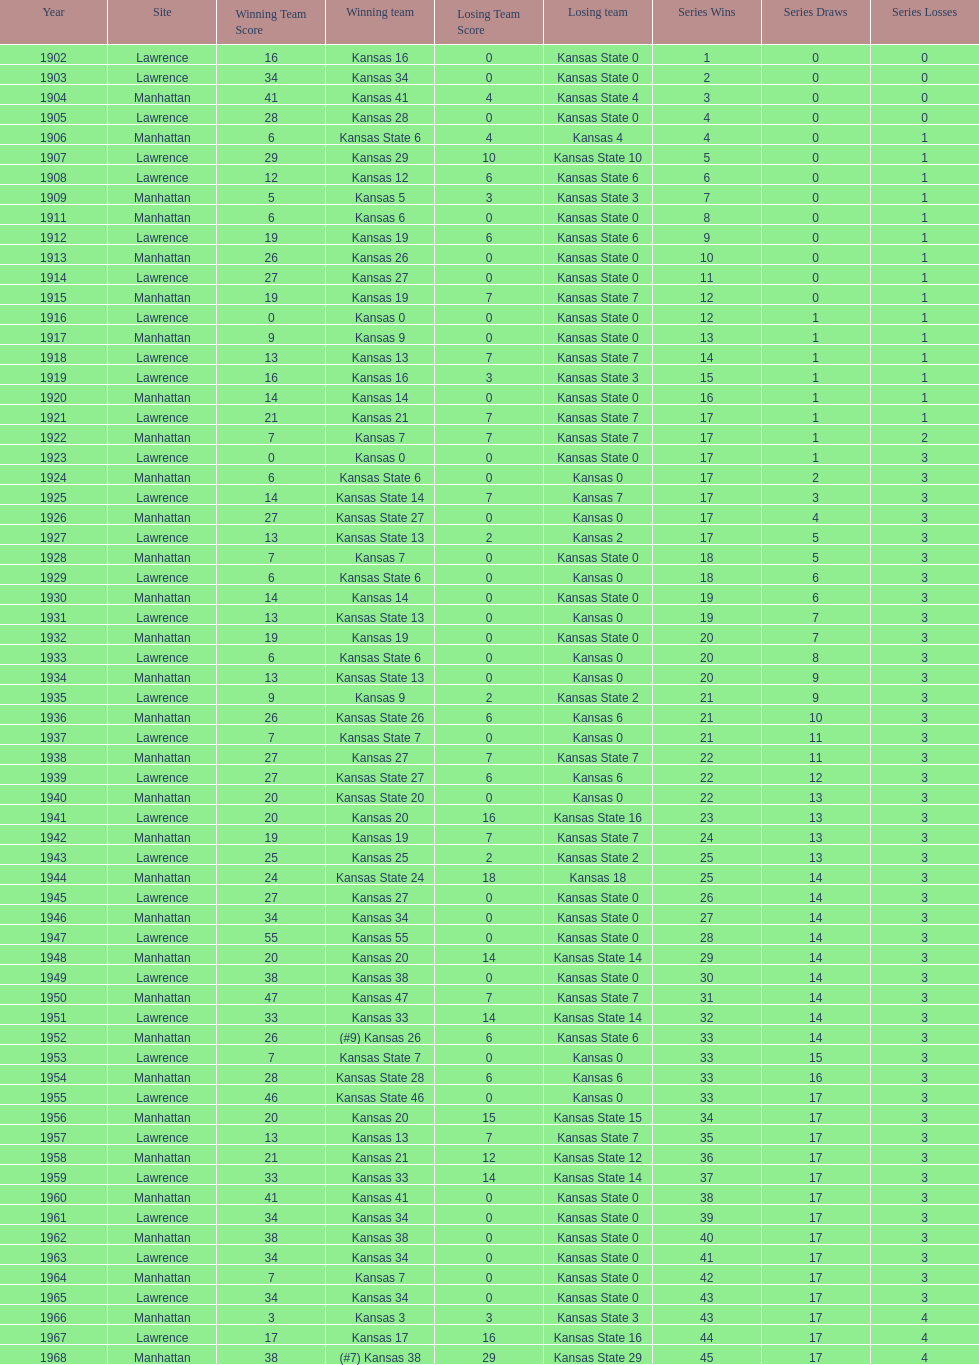When was the first game that kansas state won by double digits? 1926. 